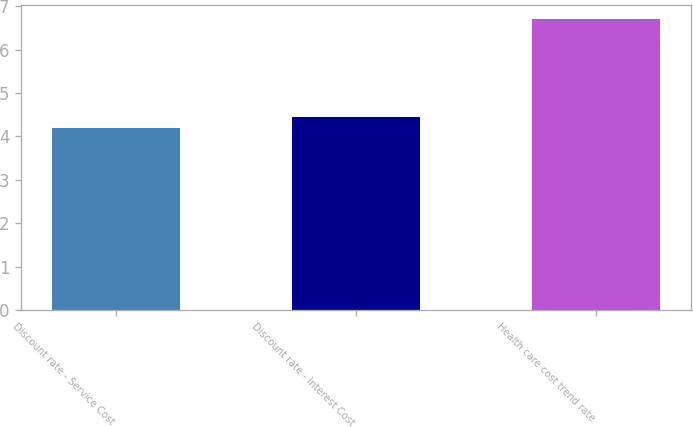<chart> <loc_0><loc_0><loc_500><loc_500><bar_chart><fcel>Discount rate - Service Cost<fcel>Discount rate - Interest Cost<fcel>Health care cost trend rate<nl><fcel>4.2<fcel>4.45<fcel>6.7<nl></chart> 